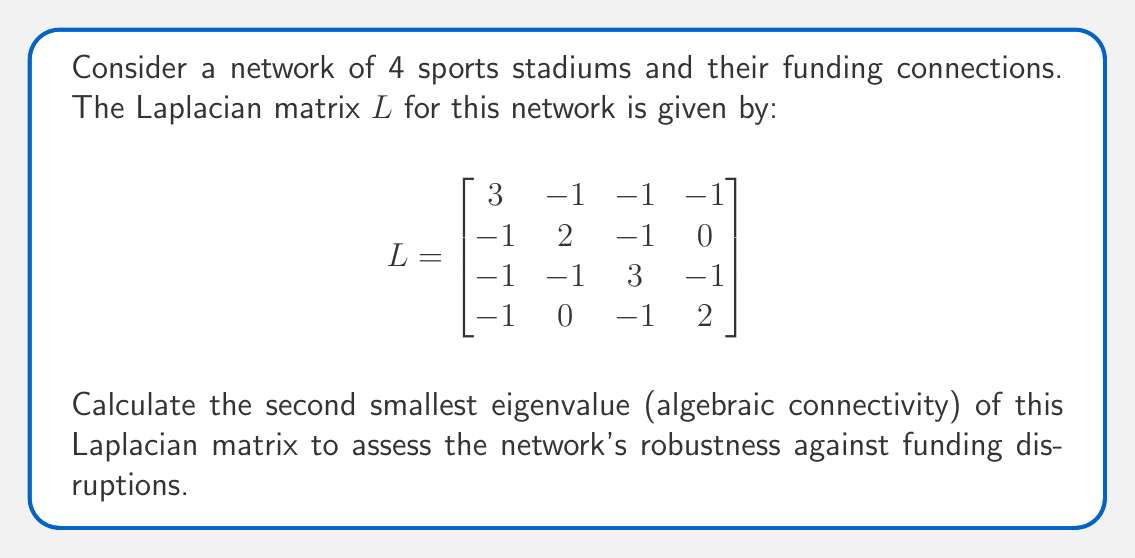Show me your answer to this math problem. To find the second smallest eigenvalue of the Laplacian matrix:

1) First, we need to find the characteristic equation:
   $\det(L - \lambda I) = 0$

2) Expanding the determinant:
   $$\begin{vmatrix}
   3-\lambda & -1 & -1 & -1 \\
   -1 & 2-\lambda & -1 & 0 \\
   -1 & -1 & 3-\lambda & -1 \\
   -1 & 0 & -1 & 2-\lambda
   \end{vmatrix} = 0$$

3) Calculating the determinant (using cofactor expansion or a computer algebra system):
   $\lambda^4 - 10\lambda^3 + 31\lambda^2 - 30\lambda = 0$

4) Factoring the equation:
   $\lambda(\lambda^3 - 10\lambda^2 + 31\lambda - 30) = 0$
   $\lambda(\lambda - 1)(\lambda - 4)(\lambda - 5) = 0$

5) The eigenvalues are:
   $\lambda_1 = 0$, $\lambda_2 = 1$, $\lambda_3 = 4$, $\lambda_4 = 5$

6) The second smallest eigenvalue (algebraic connectivity) is $\lambda_2 = 1$.

This value indicates the network's connectivity and robustness against funding disruptions. A higher value would suggest a more well-connected and resilient funding network.
Answer: $1$ 